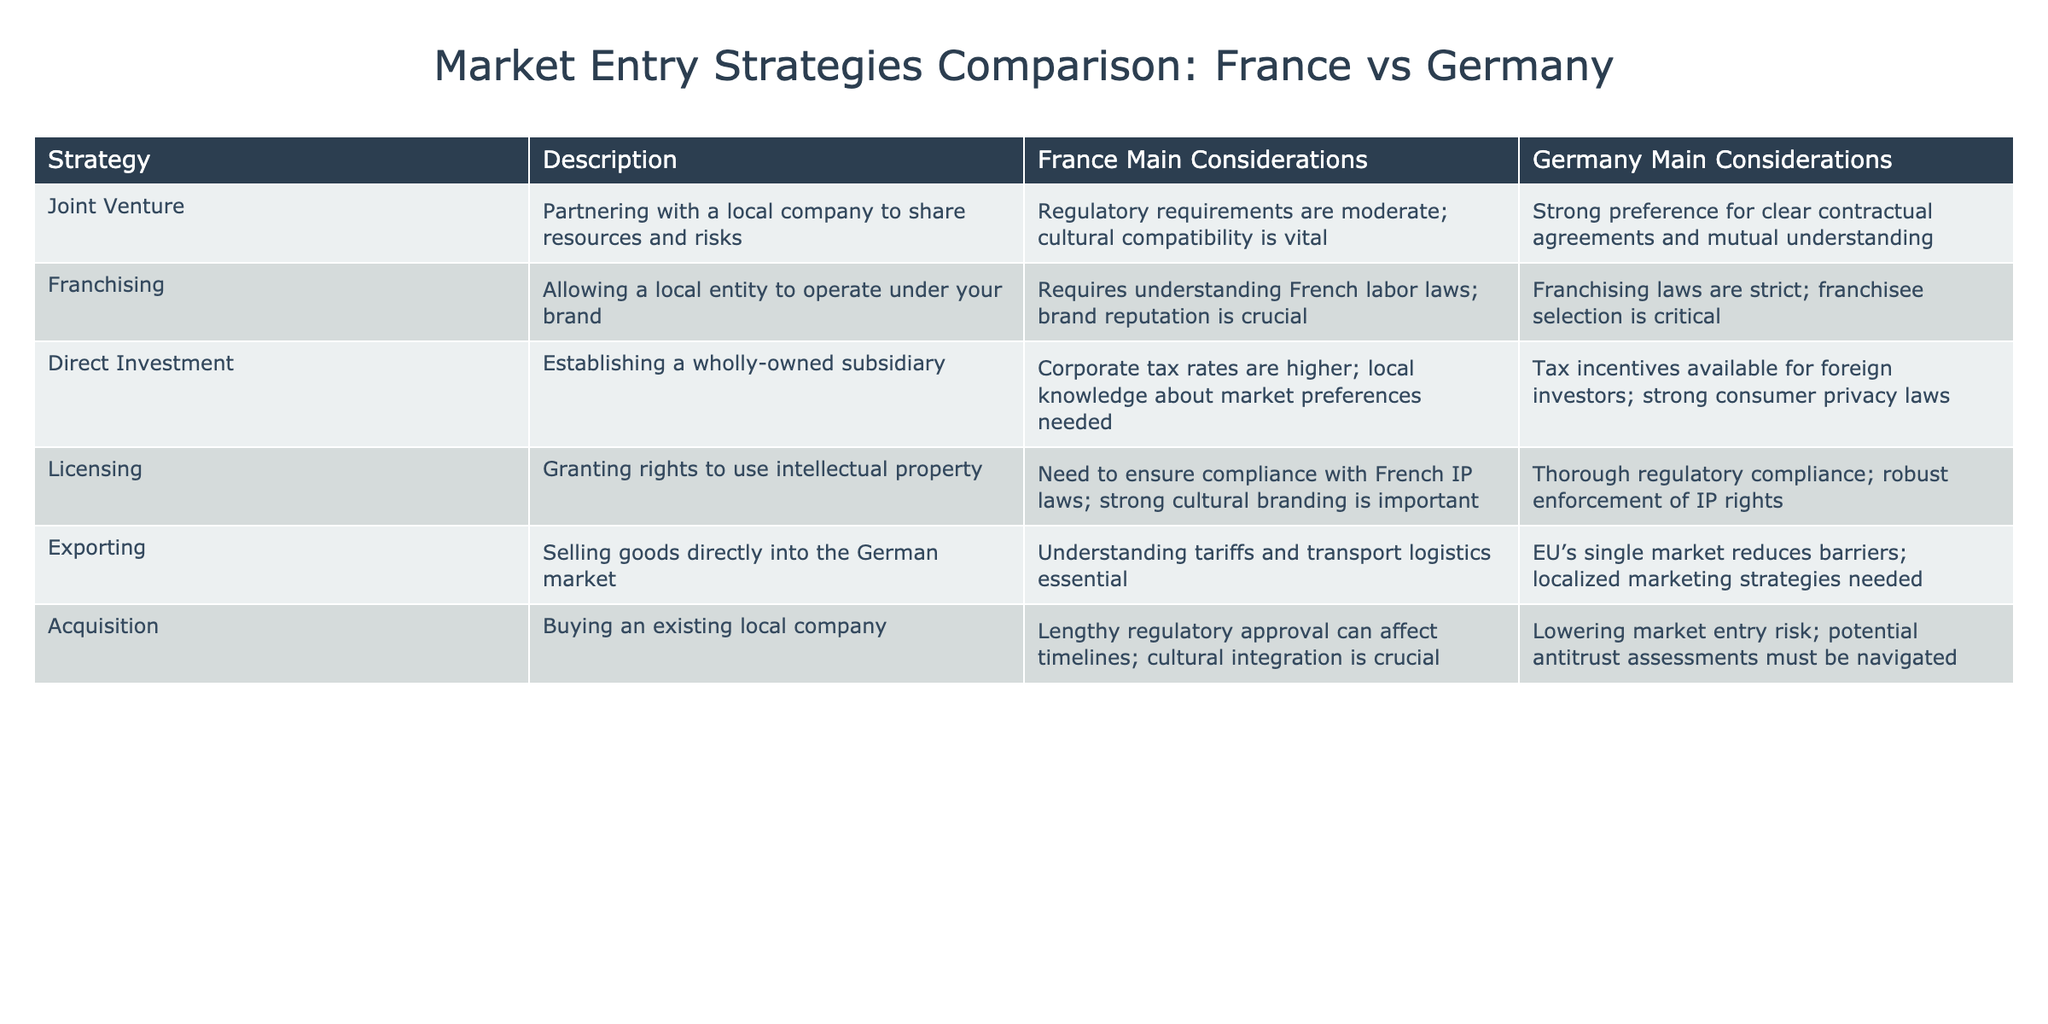What are the main considerations for Joint Ventures in France? The table indicates that the main considerations for Joint Ventures in France are moderate regulatory requirements and a vital need for cultural compatibility.
Answer: Regulatory requirements are moderate; cultural compatibility is vital What are the franchisee selection considerations in Germany? According to the table, franchises in Germany have strict laws, and selecting the right franchisee is critical for success.
Answer: Franchising laws are strict; franchisee selection is critical Is direct investment a viable strategy for foreign investors in Germany? Yes, the table shows that there are tax incentives available for foreign investors when establishing a wholly-owned subsidiary in Germany.
Answer: Yes Which market entry strategy has a stronger emphasis on intellectual property compliance in Germany? The licensing strategy has thorough regulatory compliance and robust enforcement of intellectual property rights as its primary consideration in Germany.
Answer: Licensing What is the difference in regulatory hurdles when considering acquisitions in France versus Germany? In France, regulatory approval can be lengthy and impact timelines, while in Germany, it helps lower market entry risk but involves potential antitrust assessments.
Answer: Lengthy regulatory approval in France; lower risk but antitrust assessments in Germany What is the average consideration focus for importing and exporting? Focusing on the considerations provided in the table, we summarize Importing (Joint Venture, Direct Investment, Licensing) and Exporting (Exporting). The average focus shows a heavier emphasis on logistics concerning exporting in Germany, combined with tariff understanding for importing into Germany (which is crucial).
Answer: Emphasis on logistics (exporting) in Germany; tariff understanding for importing Are acquiring local companies more challenging in France compared to Germany? Yes, the table states that acquisitions in France involve lengthy regulatory approvals, making them potentially more challenging than in Germany, where the risks are lower due to established companies.
Answer: Yes 